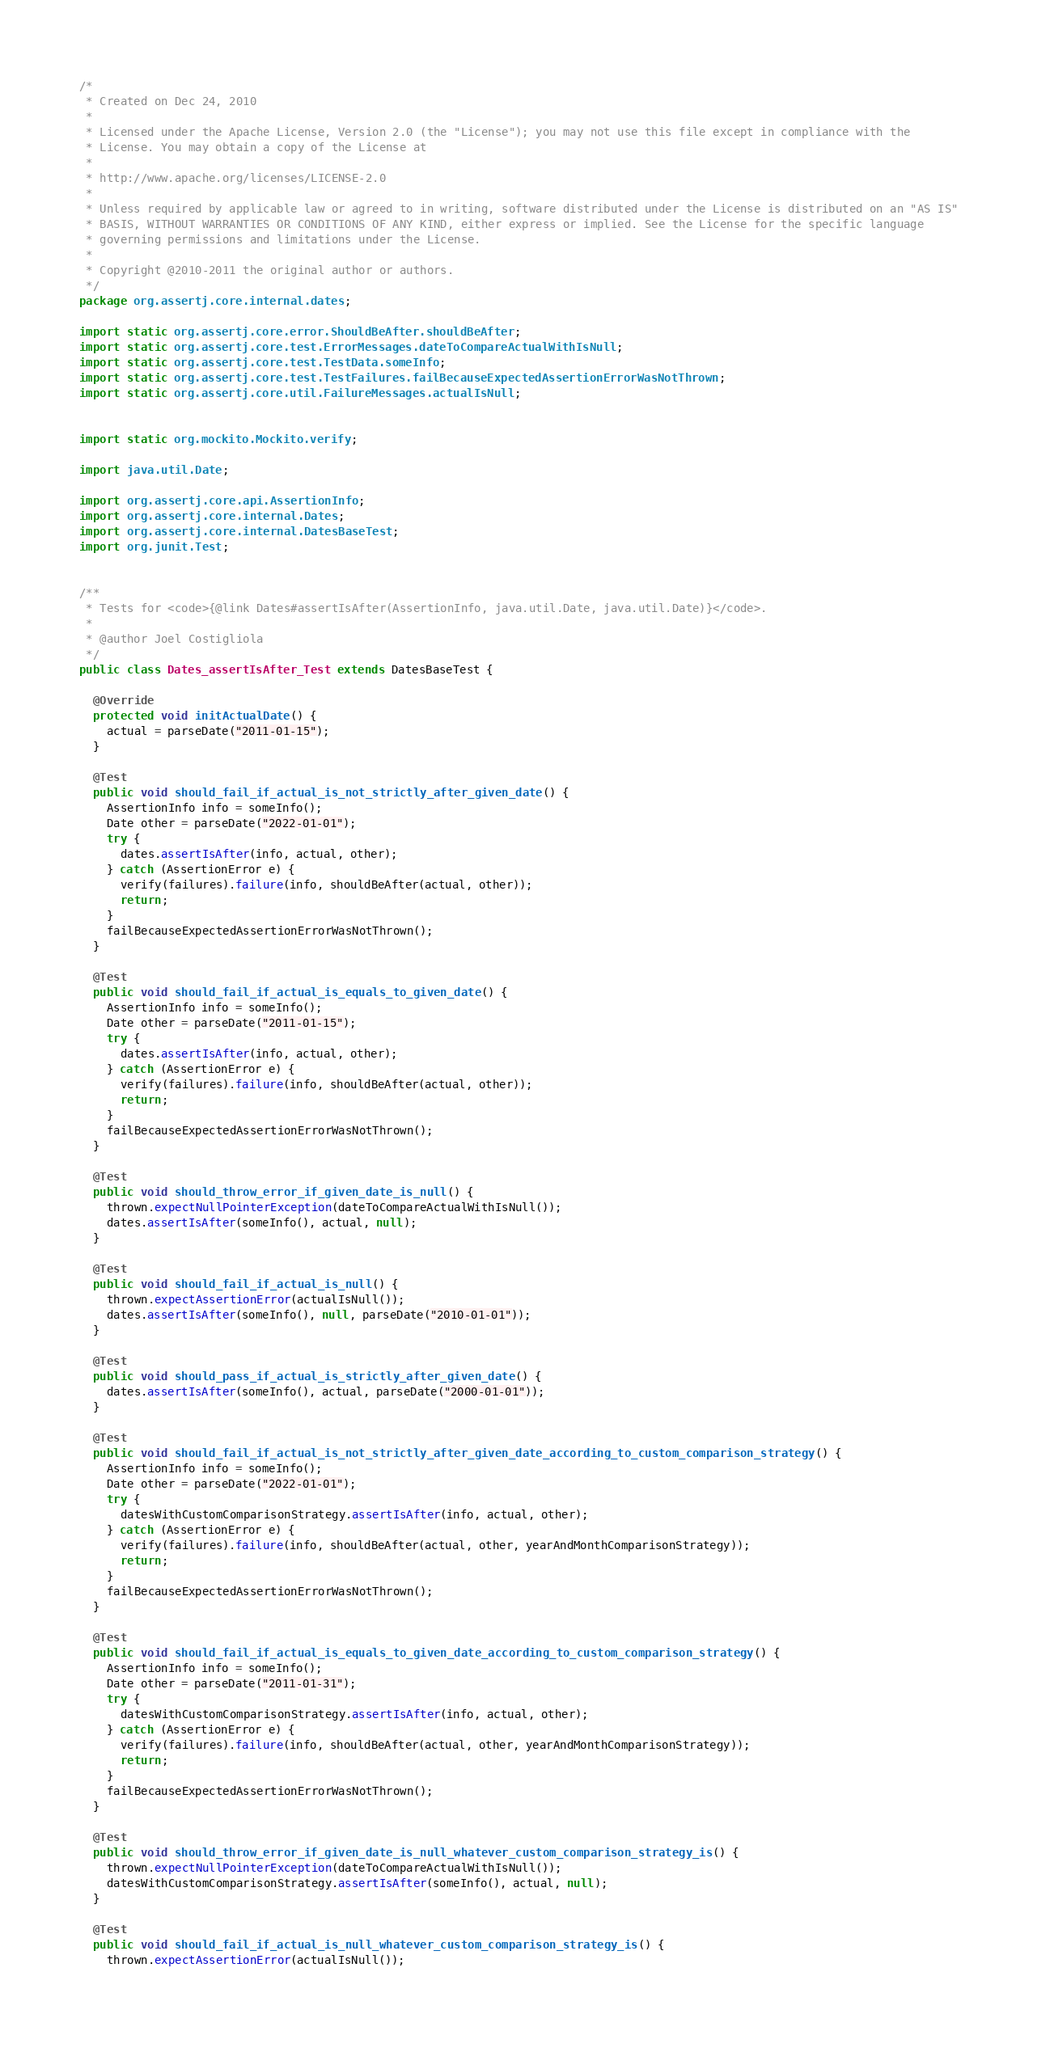<code> <loc_0><loc_0><loc_500><loc_500><_Java_>/*
 * Created on Dec 24, 2010
 * 
 * Licensed under the Apache License, Version 2.0 (the "License"); you may not use this file except in compliance with the
 * License. You may obtain a copy of the License at
 * 
 * http://www.apache.org/licenses/LICENSE-2.0
 * 
 * Unless required by applicable law or agreed to in writing, software distributed under the License is distributed on an "AS IS"
 * BASIS, WITHOUT WARRANTIES OR CONDITIONS OF ANY KIND, either express or implied. See the License for the specific language
 * governing permissions and limitations under the License.
 * 
 * Copyright @2010-2011 the original author or authors.
 */
package org.assertj.core.internal.dates;

import static org.assertj.core.error.ShouldBeAfter.shouldBeAfter;
import static org.assertj.core.test.ErrorMessages.dateToCompareActualWithIsNull;
import static org.assertj.core.test.TestData.someInfo;
import static org.assertj.core.test.TestFailures.failBecauseExpectedAssertionErrorWasNotThrown;
import static org.assertj.core.util.FailureMessages.actualIsNull;


import static org.mockito.Mockito.verify;

import java.util.Date;

import org.assertj.core.api.AssertionInfo;
import org.assertj.core.internal.Dates;
import org.assertj.core.internal.DatesBaseTest;
import org.junit.Test;


/**
 * Tests for <code>{@link Dates#assertIsAfter(AssertionInfo, java.util.Date, java.util.Date)}</code>.
 * 
 * @author Joel Costigliola
 */
public class Dates_assertIsAfter_Test extends DatesBaseTest {

  @Override
  protected void initActualDate() {
    actual = parseDate("2011-01-15");
  }

  @Test
  public void should_fail_if_actual_is_not_strictly_after_given_date() {
    AssertionInfo info = someInfo();
    Date other = parseDate("2022-01-01");
    try {
      dates.assertIsAfter(info, actual, other);
    } catch (AssertionError e) {
      verify(failures).failure(info, shouldBeAfter(actual, other));
      return;
    }
    failBecauseExpectedAssertionErrorWasNotThrown();
  }

  @Test
  public void should_fail_if_actual_is_equals_to_given_date() {
    AssertionInfo info = someInfo();
    Date other = parseDate("2011-01-15");
    try {
      dates.assertIsAfter(info, actual, other);
    } catch (AssertionError e) {
      verify(failures).failure(info, shouldBeAfter(actual, other));
      return;
    }
    failBecauseExpectedAssertionErrorWasNotThrown();
  }

  @Test
  public void should_throw_error_if_given_date_is_null() {
    thrown.expectNullPointerException(dateToCompareActualWithIsNull());
    dates.assertIsAfter(someInfo(), actual, null);
  }

  @Test
  public void should_fail_if_actual_is_null() {
    thrown.expectAssertionError(actualIsNull());
    dates.assertIsAfter(someInfo(), null, parseDate("2010-01-01"));
  }

  @Test
  public void should_pass_if_actual_is_strictly_after_given_date() {
    dates.assertIsAfter(someInfo(), actual, parseDate("2000-01-01"));
  }

  @Test
  public void should_fail_if_actual_is_not_strictly_after_given_date_according_to_custom_comparison_strategy() {
    AssertionInfo info = someInfo();
    Date other = parseDate("2022-01-01");
    try {
      datesWithCustomComparisonStrategy.assertIsAfter(info, actual, other);
    } catch (AssertionError e) {
      verify(failures).failure(info, shouldBeAfter(actual, other, yearAndMonthComparisonStrategy));
      return;
    }
    failBecauseExpectedAssertionErrorWasNotThrown();
  }

  @Test
  public void should_fail_if_actual_is_equals_to_given_date_according_to_custom_comparison_strategy() {
    AssertionInfo info = someInfo();
    Date other = parseDate("2011-01-31");
    try {
      datesWithCustomComparisonStrategy.assertIsAfter(info, actual, other);
    } catch (AssertionError e) {
      verify(failures).failure(info, shouldBeAfter(actual, other, yearAndMonthComparisonStrategy));
      return;
    }
    failBecauseExpectedAssertionErrorWasNotThrown();
  }

  @Test
  public void should_throw_error_if_given_date_is_null_whatever_custom_comparison_strategy_is() {
    thrown.expectNullPointerException(dateToCompareActualWithIsNull());
    datesWithCustomComparisonStrategy.assertIsAfter(someInfo(), actual, null);
  }

  @Test
  public void should_fail_if_actual_is_null_whatever_custom_comparison_strategy_is() {
    thrown.expectAssertionError(actualIsNull());</code> 